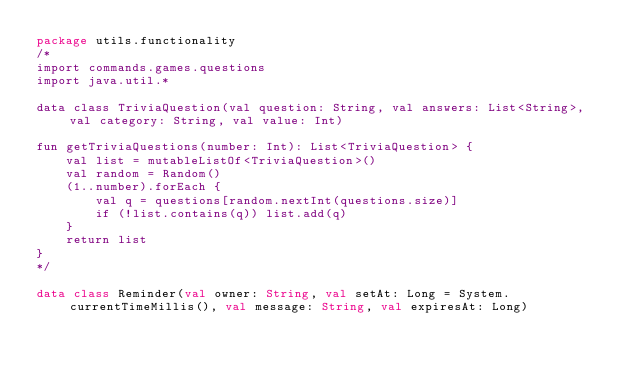Convert code to text. <code><loc_0><loc_0><loc_500><loc_500><_Kotlin_>package utils.functionality
/*
import commands.games.questions
import java.util.*

data class TriviaQuestion(val question: String, val answers: List<String>, val category: String, val value: Int)

fun getTriviaQuestions(number: Int): List<TriviaQuestion> {
    val list = mutableListOf<TriviaQuestion>()
    val random = Random()
    (1..number).forEach {
        val q = questions[random.nextInt(questions.size)]
        if (!list.contains(q)) list.add(q)
    }
    return list
}
*/

data class Reminder(val owner: String, val setAt: Long = System.currentTimeMillis(), val message: String, val expiresAt: Long)</code> 